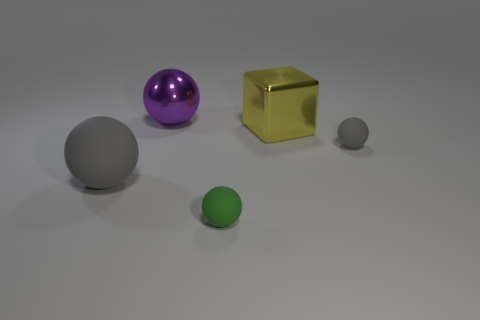Subtract 1 balls. How many balls are left? 3 Add 1 metallic cubes. How many objects exist? 6 Subtract all blue cubes. Subtract all blue cylinders. How many cubes are left? 1 Subtract all balls. How many objects are left? 1 Add 2 large rubber balls. How many large rubber balls exist? 3 Subtract 1 purple balls. How many objects are left? 4 Subtract all cyan rubber balls. Subtract all small green balls. How many objects are left? 4 Add 2 shiny spheres. How many shiny spheres are left? 3 